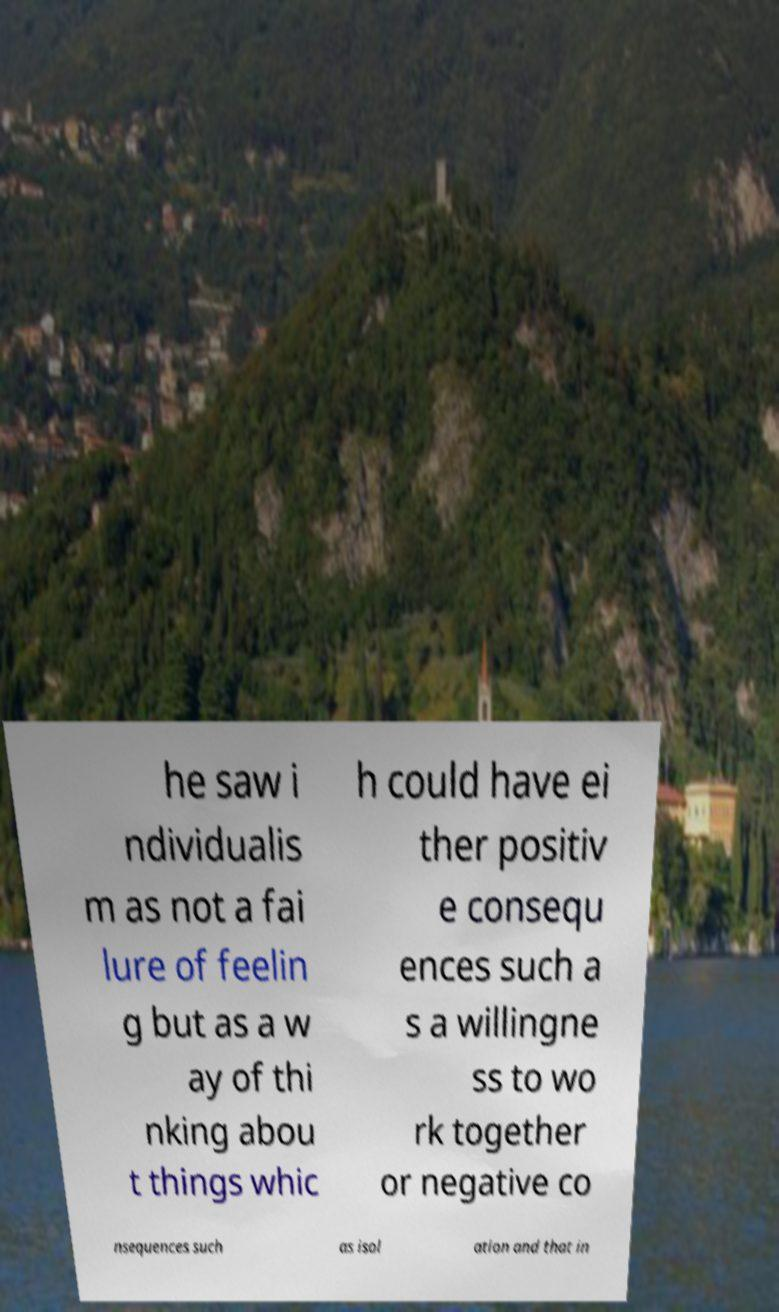Can you accurately transcribe the text from the provided image for me? he saw i ndividualis m as not a fai lure of feelin g but as a w ay of thi nking abou t things whic h could have ei ther positiv e consequ ences such a s a willingne ss to wo rk together or negative co nsequences such as isol ation and that in 